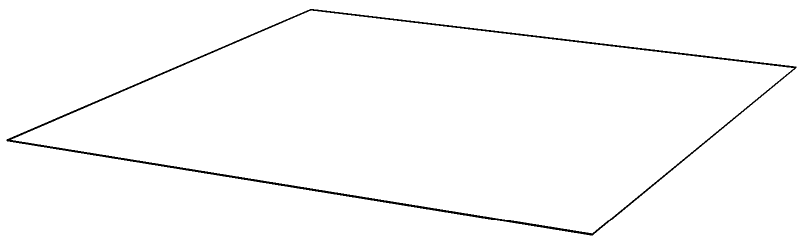A regular octahedron is a three-dimensional shape with 8 faces, all of which are equilateral triangles. If the edge length of this octahedron is 2 units, what is its total surface area? To find the surface area of a regular octahedron, we can follow these steps:

1) First, we need to understand that a regular octahedron has 8 identical equilateral triangle faces.

2) The surface area will be the sum of the areas of all 8 triangles.

3) To find the area of one equilateral triangle:
   - The formula for the area of an equilateral triangle is: $A = \frac{\sqrt{3}}{4}a^2$, where $a$ is the side length.
   - In this case, $a = 2$ units.

4) Let's calculate the area of one triangle:
   $A = \frac{\sqrt{3}}{4}(2)^2 = \sqrt{3}$ square units

5) Since there are 8 identical triangles, we multiply this area by 8:
   Total Surface Area $= 8 \times \sqrt{3}$ square units

6) Simplifying:
   Total Surface Area $= 8\sqrt{3}$ square units

Therefore, the total surface area of the regular octahedron is $8\sqrt{3}$ square units.
Answer: $8\sqrt{3}$ square units 